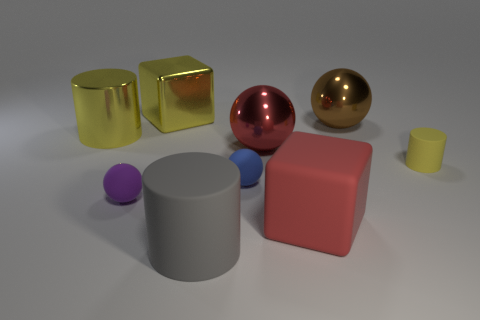Subtract all brown spheres. How many yellow cylinders are left? 2 Subtract all tiny cylinders. How many cylinders are left? 2 Subtract all red spheres. How many spheres are left? 3 Add 1 large gray rubber things. How many objects exist? 10 Subtract all blue balls. Subtract all red cylinders. How many balls are left? 3 Subtract all spheres. How many objects are left? 5 Subtract all small green rubber things. Subtract all large objects. How many objects are left? 3 Add 2 big red objects. How many big red objects are left? 4 Add 1 matte spheres. How many matte spheres exist? 3 Subtract 0 green balls. How many objects are left? 9 